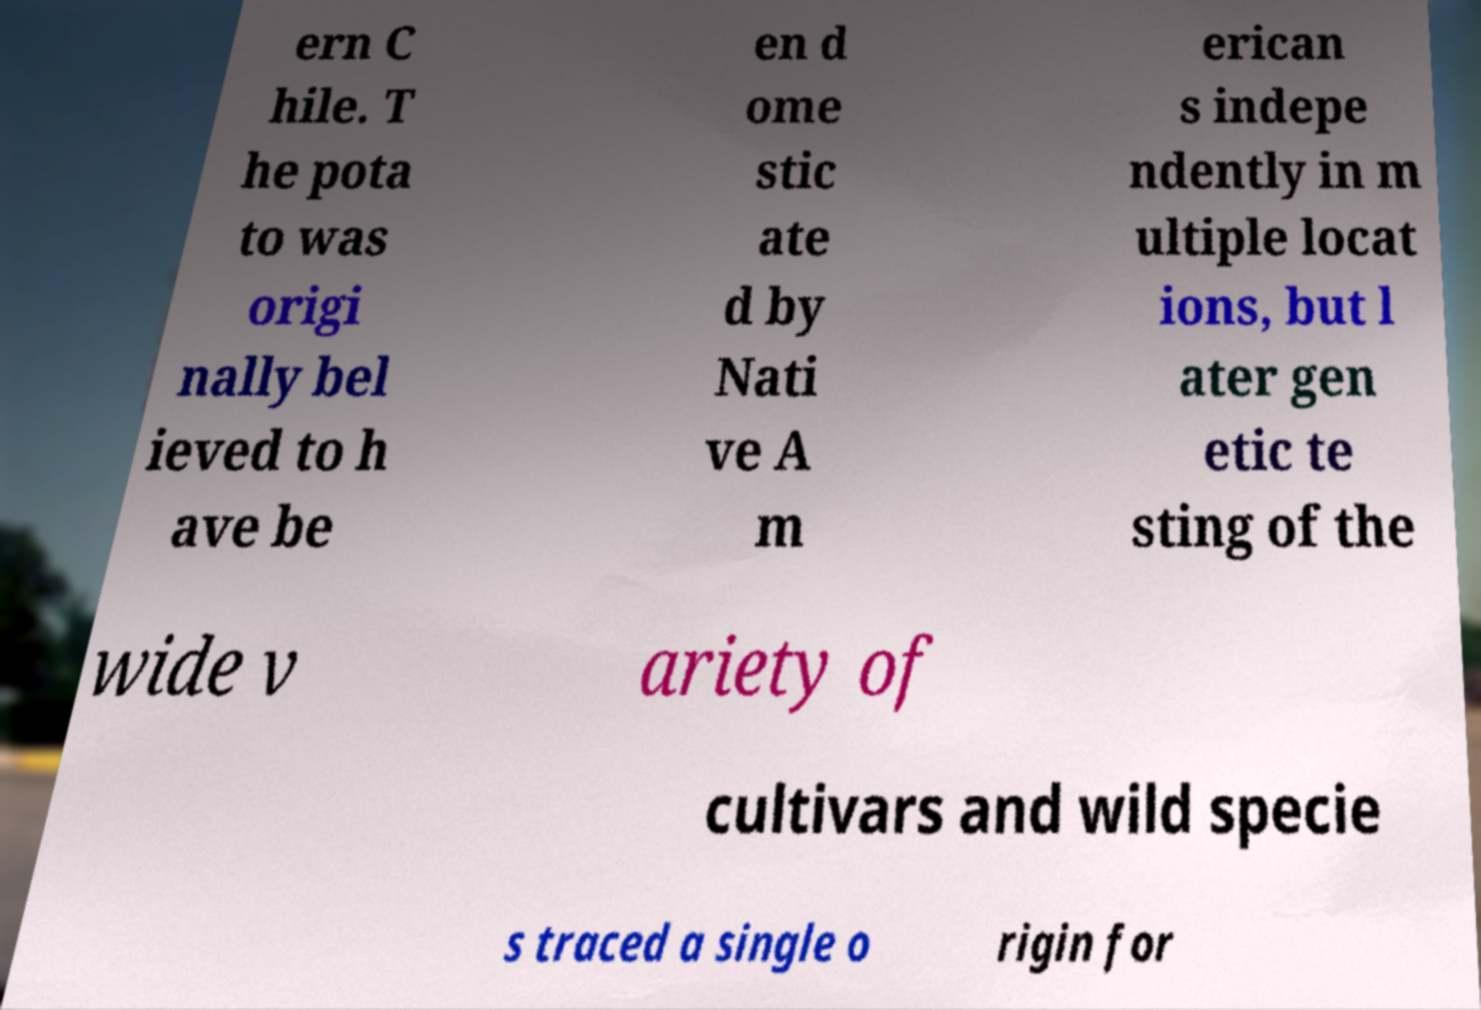What messages or text are displayed in this image? I need them in a readable, typed format. ern C hile. T he pota to was origi nally bel ieved to h ave be en d ome stic ate d by Nati ve A m erican s indepe ndently in m ultiple locat ions, but l ater gen etic te sting of the wide v ariety of cultivars and wild specie s traced a single o rigin for 